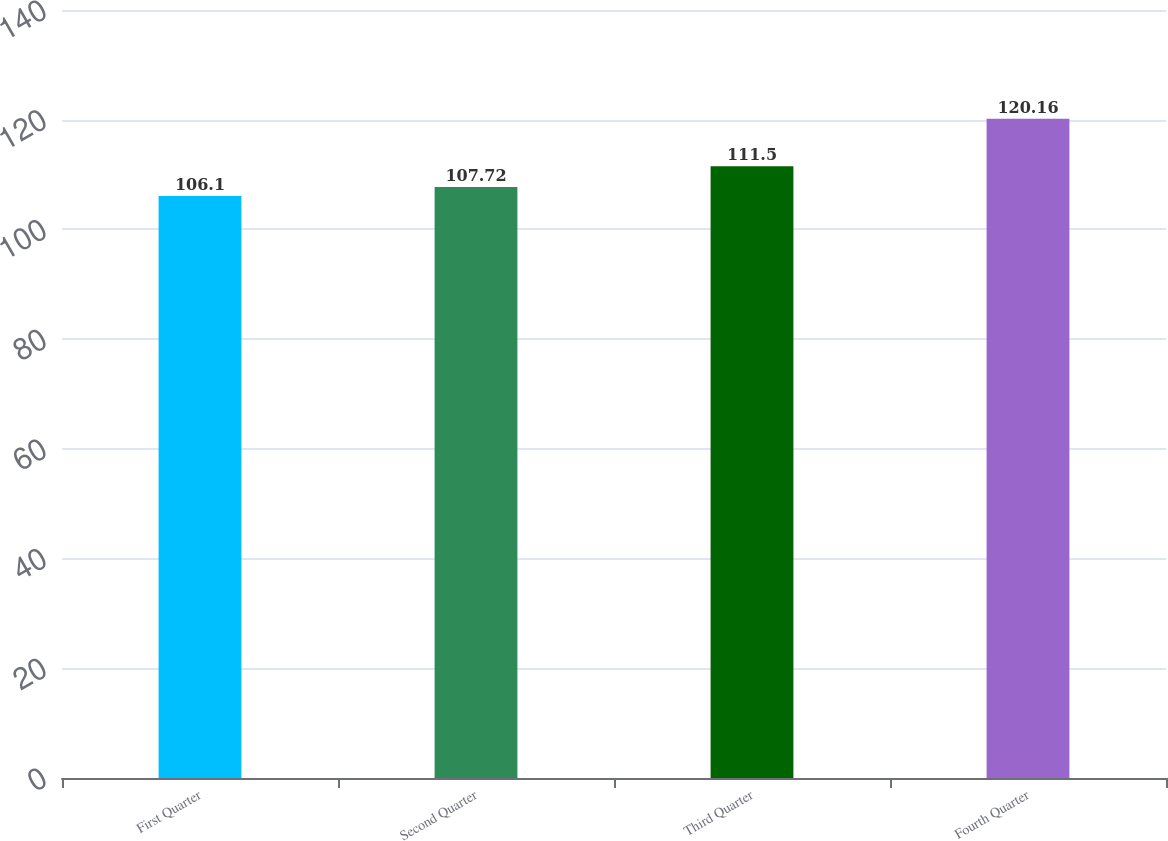<chart> <loc_0><loc_0><loc_500><loc_500><bar_chart><fcel>First Quarter<fcel>Second Quarter<fcel>Third Quarter<fcel>Fourth Quarter<nl><fcel>106.1<fcel>107.72<fcel>111.5<fcel>120.16<nl></chart> 